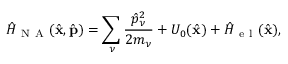Convert formula to latex. <formula><loc_0><loc_0><loc_500><loc_500>\hat { H } _ { N A } ( \hat { x } , \hat { p } ) = \sum _ { \nu } \frac { \hat { p } _ { \nu } ^ { 2 } } { 2 m _ { \nu } } + U _ { 0 } ( \hat { x } ) + \hat { H } _ { e l } ( \hat { x } ) ,</formula> 